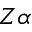<formula> <loc_0><loc_0><loc_500><loc_500>Z \alpha</formula> 